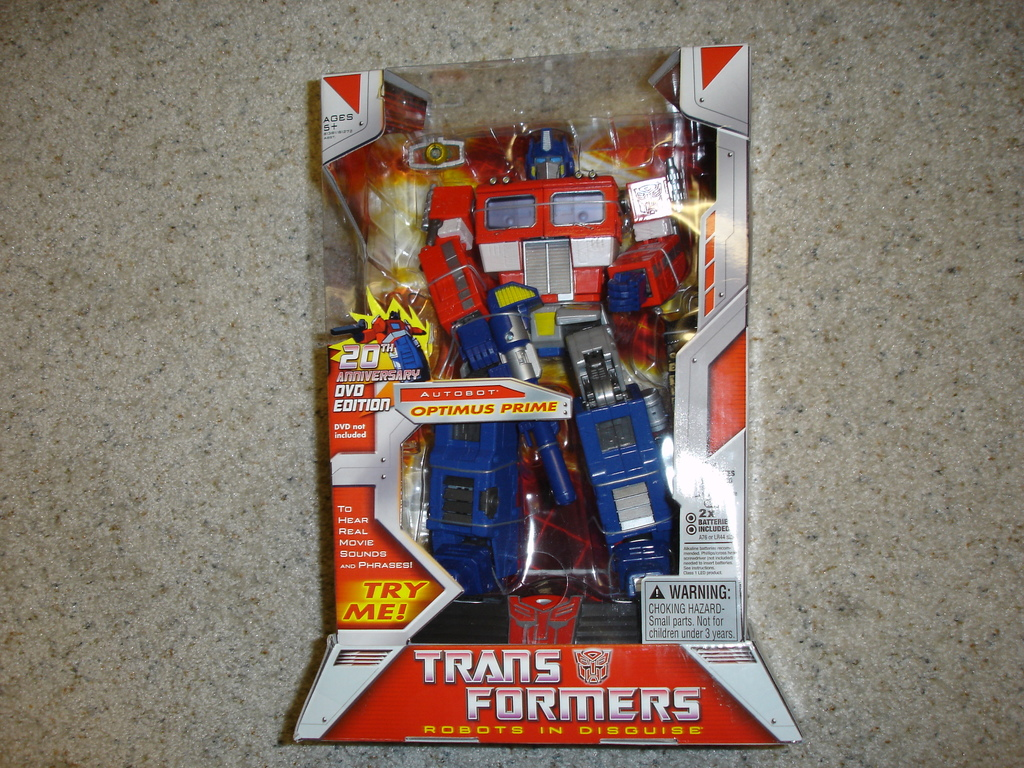Provide a one-sentence caption for the provided image. The image showcases a 'Transformers: Robots in Disguise' Optimus Prime toy in its '20th Anniversary DVD Edition' packaging, featuring notable call-outs like 'Try Me!' to indicate interactive sound features. 